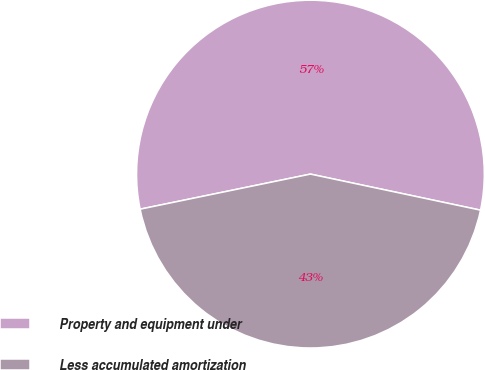<chart> <loc_0><loc_0><loc_500><loc_500><pie_chart><fcel>Property and equipment under<fcel>Less accumulated amortization<nl><fcel>56.56%<fcel>43.44%<nl></chart> 